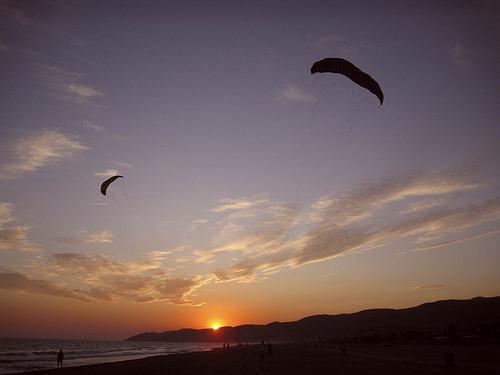How many large kites are in the sky?
Give a very brief answer. 2. How many kites are shown?
Give a very brief answer. 2. 